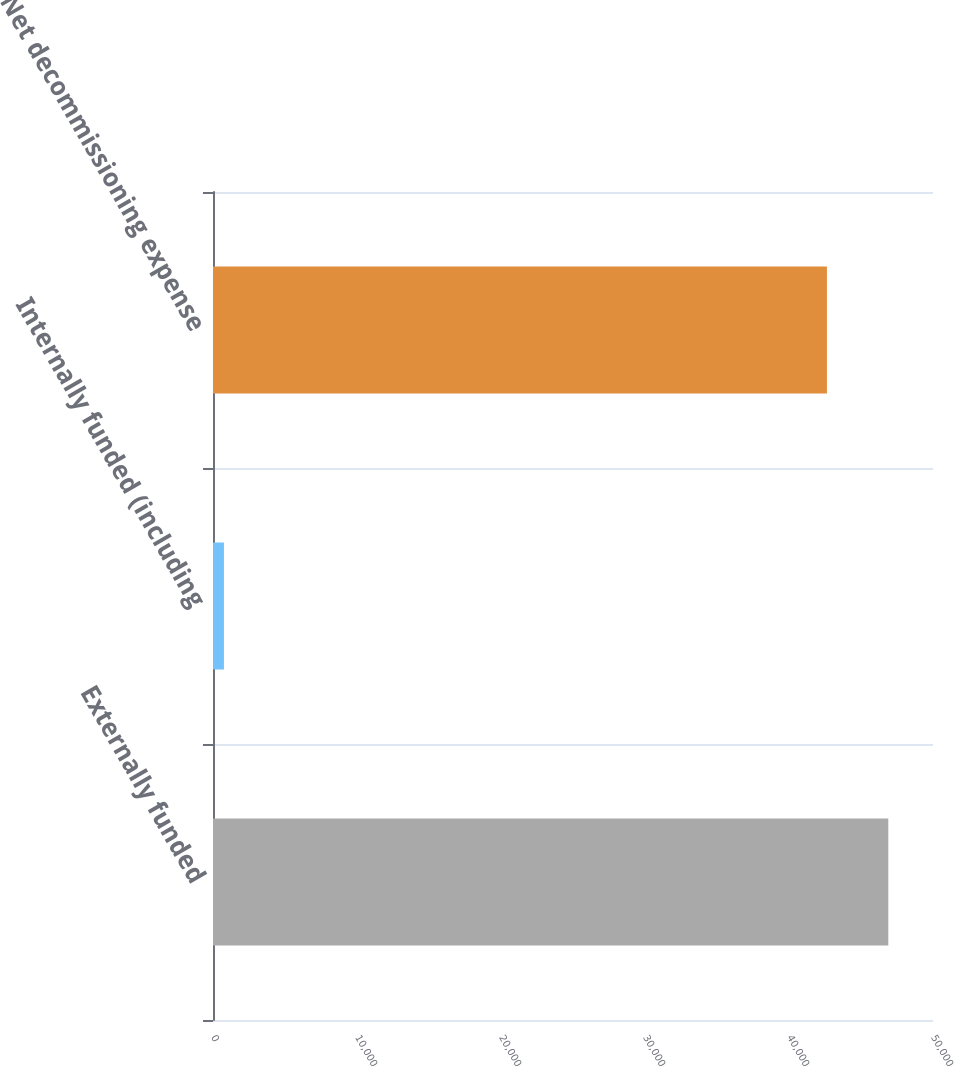Convert chart to OTSL. <chart><loc_0><loc_0><loc_500><loc_500><bar_chart><fcel>Externally funded<fcel>Internally funded (including<fcel>Net decommissioning expense<nl><fcel>46896.3<fcel>759<fcel>42633<nl></chart> 